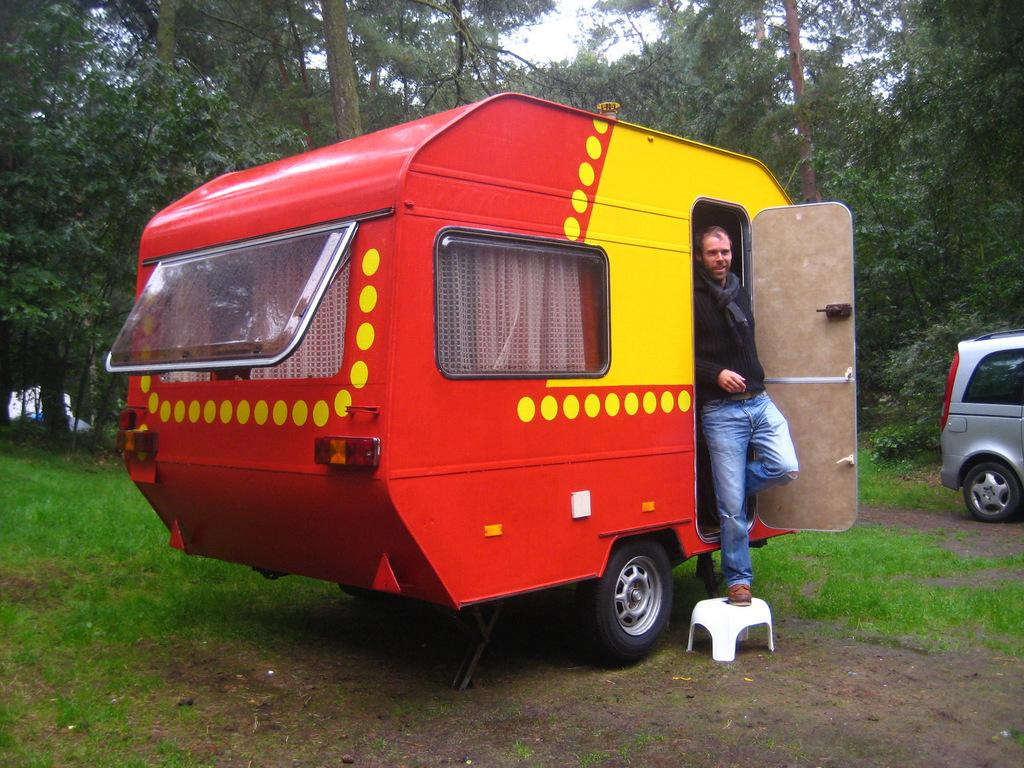What types of objects are present in the image? There are vehicles and a man in the image. What can be seen in the background of the image? There is grass and trees visible in the image. What type of quill is the man using to write on the page in the image? There is no quill or page present in the image; the man is not depicted as writing. 